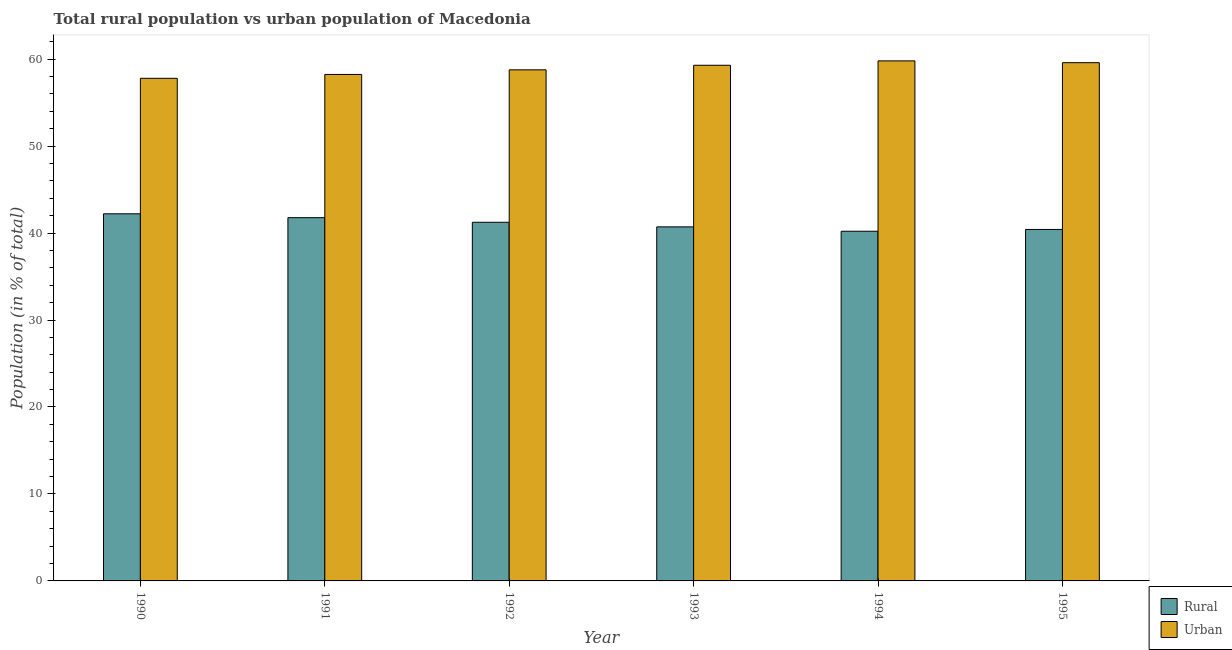How many different coloured bars are there?
Offer a terse response. 2. How many groups of bars are there?
Provide a succinct answer. 6. In how many cases, is the number of bars for a given year not equal to the number of legend labels?
Make the answer very short. 0. What is the urban population in 1991?
Make the answer very short. 58.23. Across all years, what is the maximum rural population?
Your response must be concise. 42.21. Across all years, what is the minimum rural population?
Offer a terse response. 40.21. In which year was the rural population maximum?
Your response must be concise. 1990. In which year was the rural population minimum?
Offer a very short reply. 1994. What is the total rural population in the graph?
Make the answer very short. 246.54. What is the difference between the rural population in 1990 and that in 1994?
Your answer should be very brief. 2.01. What is the difference between the urban population in 1990 and the rural population in 1994?
Your answer should be very brief. -2. What is the average urban population per year?
Your answer should be compact. 58.91. In the year 1992, what is the difference between the rural population and urban population?
Your answer should be very brief. 0. In how many years, is the urban population greater than 56 %?
Your response must be concise. 6. What is the ratio of the urban population in 1991 to that in 1994?
Keep it short and to the point. 0.97. Is the urban population in 1990 less than that in 1991?
Offer a very short reply. Yes. What is the difference between the highest and the second highest urban population?
Your answer should be compact. 0.21. What is the difference between the highest and the lowest urban population?
Provide a short and direct response. 2. In how many years, is the urban population greater than the average urban population taken over all years?
Make the answer very short. 3. What does the 1st bar from the left in 1992 represents?
Provide a succinct answer. Rural. What does the 2nd bar from the right in 1995 represents?
Provide a succinct answer. Rural. How many years are there in the graph?
Your answer should be compact. 6. Does the graph contain grids?
Offer a terse response. No. Where does the legend appear in the graph?
Offer a terse response. Bottom right. How many legend labels are there?
Your response must be concise. 2. How are the legend labels stacked?
Give a very brief answer. Vertical. What is the title of the graph?
Your answer should be compact. Total rural population vs urban population of Macedonia. Does "Overweight" appear as one of the legend labels in the graph?
Offer a terse response. No. What is the label or title of the Y-axis?
Provide a succinct answer. Population (in % of total). What is the Population (in % of total) in Rural in 1990?
Make the answer very short. 42.21. What is the Population (in % of total) in Urban in 1990?
Offer a very short reply. 57.79. What is the Population (in % of total) in Rural in 1991?
Offer a very short reply. 41.77. What is the Population (in % of total) in Urban in 1991?
Your answer should be compact. 58.23. What is the Population (in % of total) of Rural in 1992?
Your answer should be very brief. 41.24. What is the Population (in % of total) in Urban in 1992?
Provide a succinct answer. 58.76. What is the Population (in % of total) in Rural in 1993?
Your answer should be compact. 40.71. What is the Population (in % of total) in Urban in 1993?
Your response must be concise. 59.29. What is the Population (in % of total) of Rural in 1994?
Make the answer very short. 40.21. What is the Population (in % of total) of Urban in 1994?
Your answer should be compact. 59.79. What is the Population (in % of total) of Rural in 1995?
Your answer should be very brief. 40.41. What is the Population (in % of total) of Urban in 1995?
Offer a very short reply. 59.59. Across all years, what is the maximum Population (in % of total) in Rural?
Provide a short and direct response. 42.21. Across all years, what is the maximum Population (in % of total) of Urban?
Give a very brief answer. 59.79. Across all years, what is the minimum Population (in % of total) of Rural?
Make the answer very short. 40.21. Across all years, what is the minimum Population (in % of total) of Urban?
Provide a succinct answer. 57.79. What is the total Population (in % of total) in Rural in the graph?
Your response must be concise. 246.54. What is the total Population (in % of total) of Urban in the graph?
Your answer should be very brief. 353.46. What is the difference between the Population (in % of total) in Rural in 1990 and that in 1991?
Provide a short and direct response. 0.45. What is the difference between the Population (in % of total) in Urban in 1990 and that in 1991?
Give a very brief answer. -0.45. What is the difference between the Population (in % of total) of Urban in 1990 and that in 1992?
Your answer should be compact. -0.97. What is the difference between the Population (in % of total) in Rural in 1990 and that in 1993?
Make the answer very short. 1.5. What is the difference between the Population (in % of total) in Urban in 1990 and that in 1993?
Your answer should be compact. -1.5. What is the difference between the Population (in % of total) in Rural in 1990 and that in 1994?
Make the answer very short. 2. What is the difference between the Population (in % of total) in Urban in 1990 and that in 1994?
Make the answer very short. -2. What is the difference between the Population (in % of total) of Rural in 1990 and that in 1995?
Your answer should be compact. 1.8. What is the difference between the Population (in % of total) of Urban in 1990 and that in 1995?
Provide a succinct answer. -1.8. What is the difference between the Population (in % of total) of Rural in 1991 and that in 1992?
Keep it short and to the point. 0.53. What is the difference between the Population (in % of total) of Urban in 1991 and that in 1992?
Give a very brief answer. -0.53. What is the difference between the Population (in % of total) of Rural in 1991 and that in 1993?
Your answer should be very brief. 1.06. What is the difference between the Population (in % of total) in Urban in 1991 and that in 1993?
Provide a succinct answer. -1.06. What is the difference between the Population (in % of total) in Rural in 1991 and that in 1994?
Keep it short and to the point. 1.56. What is the difference between the Population (in % of total) of Urban in 1991 and that in 1994?
Your answer should be compact. -1.56. What is the difference between the Population (in % of total) in Rural in 1991 and that in 1995?
Keep it short and to the point. 1.35. What is the difference between the Population (in % of total) of Urban in 1991 and that in 1995?
Ensure brevity in your answer.  -1.35. What is the difference between the Population (in % of total) in Rural in 1992 and that in 1993?
Offer a terse response. 0.53. What is the difference between the Population (in % of total) in Urban in 1992 and that in 1993?
Give a very brief answer. -0.53. What is the difference between the Population (in % of total) of Rural in 1992 and that in 1994?
Your response must be concise. 1.03. What is the difference between the Population (in % of total) of Urban in 1992 and that in 1994?
Your answer should be very brief. -1.03. What is the difference between the Population (in % of total) of Rural in 1992 and that in 1995?
Your answer should be very brief. 0.82. What is the difference between the Population (in % of total) in Urban in 1992 and that in 1995?
Give a very brief answer. -0.82. What is the difference between the Population (in % of total) in Rural in 1993 and that in 1994?
Offer a terse response. 0.5. What is the difference between the Population (in % of total) in Urban in 1993 and that in 1994?
Provide a succinct answer. -0.5. What is the difference between the Population (in % of total) in Rural in 1993 and that in 1995?
Your answer should be very brief. 0.3. What is the difference between the Population (in % of total) of Urban in 1993 and that in 1995?
Offer a very short reply. -0.3. What is the difference between the Population (in % of total) in Rural in 1994 and that in 1995?
Your answer should be compact. -0.21. What is the difference between the Population (in % of total) of Urban in 1994 and that in 1995?
Your answer should be compact. 0.21. What is the difference between the Population (in % of total) in Rural in 1990 and the Population (in % of total) in Urban in 1991?
Offer a very short reply. -16.02. What is the difference between the Population (in % of total) in Rural in 1990 and the Population (in % of total) in Urban in 1992?
Offer a terse response. -16.55. What is the difference between the Population (in % of total) in Rural in 1990 and the Population (in % of total) in Urban in 1993?
Your answer should be compact. -17.08. What is the difference between the Population (in % of total) of Rural in 1990 and the Population (in % of total) of Urban in 1994?
Offer a very short reply. -17.58. What is the difference between the Population (in % of total) of Rural in 1990 and the Population (in % of total) of Urban in 1995?
Make the answer very short. -17.38. What is the difference between the Population (in % of total) in Rural in 1991 and the Population (in % of total) in Urban in 1992?
Your response must be concise. -17. What is the difference between the Population (in % of total) in Rural in 1991 and the Population (in % of total) in Urban in 1993?
Your answer should be very brief. -17.52. What is the difference between the Population (in % of total) in Rural in 1991 and the Population (in % of total) in Urban in 1994?
Give a very brief answer. -18.03. What is the difference between the Population (in % of total) of Rural in 1991 and the Population (in % of total) of Urban in 1995?
Provide a succinct answer. -17.82. What is the difference between the Population (in % of total) of Rural in 1992 and the Population (in % of total) of Urban in 1993?
Provide a succinct answer. -18.05. What is the difference between the Population (in % of total) of Rural in 1992 and the Population (in % of total) of Urban in 1994?
Keep it short and to the point. -18.56. What is the difference between the Population (in % of total) of Rural in 1992 and the Population (in % of total) of Urban in 1995?
Make the answer very short. -18.35. What is the difference between the Population (in % of total) in Rural in 1993 and the Population (in % of total) in Urban in 1994?
Offer a terse response. -19.09. What is the difference between the Population (in % of total) of Rural in 1993 and the Population (in % of total) of Urban in 1995?
Keep it short and to the point. -18.88. What is the difference between the Population (in % of total) of Rural in 1994 and the Population (in % of total) of Urban in 1995?
Offer a terse response. -19.38. What is the average Population (in % of total) in Rural per year?
Offer a terse response. 41.09. What is the average Population (in % of total) of Urban per year?
Give a very brief answer. 58.91. In the year 1990, what is the difference between the Population (in % of total) of Rural and Population (in % of total) of Urban?
Ensure brevity in your answer.  -15.58. In the year 1991, what is the difference between the Population (in % of total) of Rural and Population (in % of total) of Urban?
Offer a terse response. -16.47. In the year 1992, what is the difference between the Population (in % of total) of Rural and Population (in % of total) of Urban?
Your response must be concise. -17.53. In the year 1993, what is the difference between the Population (in % of total) in Rural and Population (in % of total) in Urban?
Provide a short and direct response. -18.58. In the year 1994, what is the difference between the Population (in % of total) of Rural and Population (in % of total) of Urban?
Make the answer very short. -19.59. In the year 1995, what is the difference between the Population (in % of total) in Rural and Population (in % of total) in Urban?
Keep it short and to the point. -19.17. What is the ratio of the Population (in % of total) in Rural in 1990 to that in 1991?
Your answer should be compact. 1.01. What is the ratio of the Population (in % of total) of Rural in 1990 to that in 1992?
Your response must be concise. 1.02. What is the ratio of the Population (in % of total) in Urban in 1990 to that in 1992?
Ensure brevity in your answer.  0.98. What is the ratio of the Population (in % of total) of Rural in 1990 to that in 1993?
Offer a very short reply. 1.04. What is the ratio of the Population (in % of total) of Urban in 1990 to that in 1993?
Your answer should be very brief. 0.97. What is the ratio of the Population (in % of total) in Rural in 1990 to that in 1994?
Provide a short and direct response. 1.05. What is the ratio of the Population (in % of total) in Urban in 1990 to that in 1994?
Ensure brevity in your answer.  0.97. What is the ratio of the Population (in % of total) of Rural in 1990 to that in 1995?
Ensure brevity in your answer.  1.04. What is the ratio of the Population (in % of total) in Urban in 1990 to that in 1995?
Your response must be concise. 0.97. What is the ratio of the Population (in % of total) of Rural in 1991 to that in 1992?
Keep it short and to the point. 1.01. What is the ratio of the Population (in % of total) in Urban in 1991 to that in 1993?
Keep it short and to the point. 0.98. What is the ratio of the Population (in % of total) in Rural in 1991 to that in 1994?
Your answer should be compact. 1.04. What is the ratio of the Population (in % of total) in Urban in 1991 to that in 1994?
Keep it short and to the point. 0.97. What is the ratio of the Population (in % of total) in Rural in 1991 to that in 1995?
Provide a succinct answer. 1.03. What is the ratio of the Population (in % of total) in Urban in 1991 to that in 1995?
Offer a very short reply. 0.98. What is the ratio of the Population (in % of total) of Rural in 1992 to that in 1993?
Make the answer very short. 1.01. What is the ratio of the Population (in % of total) in Rural in 1992 to that in 1994?
Provide a succinct answer. 1.03. What is the ratio of the Population (in % of total) of Urban in 1992 to that in 1994?
Your answer should be compact. 0.98. What is the ratio of the Population (in % of total) in Rural in 1992 to that in 1995?
Your answer should be very brief. 1.02. What is the ratio of the Population (in % of total) of Urban in 1992 to that in 1995?
Give a very brief answer. 0.99. What is the ratio of the Population (in % of total) in Rural in 1993 to that in 1994?
Make the answer very short. 1.01. What is the ratio of the Population (in % of total) in Rural in 1993 to that in 1995?
Keep it short and to the point. 1.01. What is the ratio of the Population (in % of total) of Urban in 1994 to that in 1995?
Your response must be concise. 1. What is the difference between the highest and the second highest Population (in % of total) of Rural?
Make the answer very short. 0.45. What is the difference between the highest and the second highest Population (in % of total) of Urban?
Keep it short and to the point. 0.21. What is the difference between the highest and the lowest Population (in % of total) of Rural?
Provide a short and direct response. 2. What is the difference between the highest and the lowest Population (in % of total) in Urban?
Your answer should be compact. 2. 